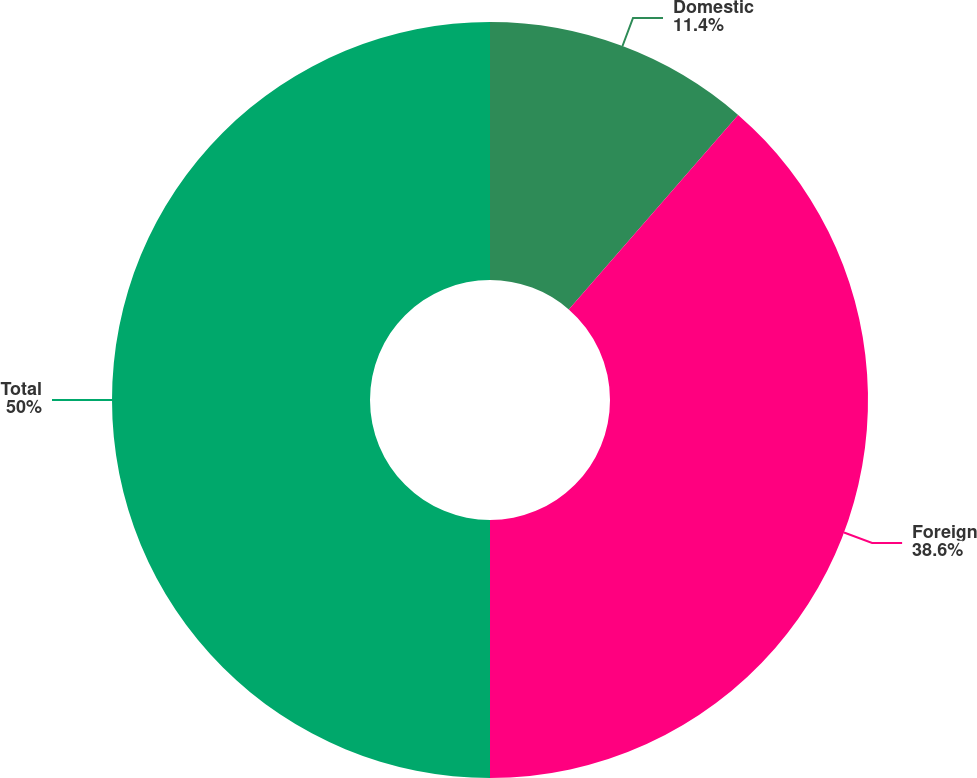Convert chart to OTSL. <chart><loc_0><loc_0><loc_500><loc_500><pie_chart><fcel>Domestic<fcel>Foreign<fcel>Total<nl><fcel>11.4%<fcel>38.6%<fcel>50.0%<nl></chart> 